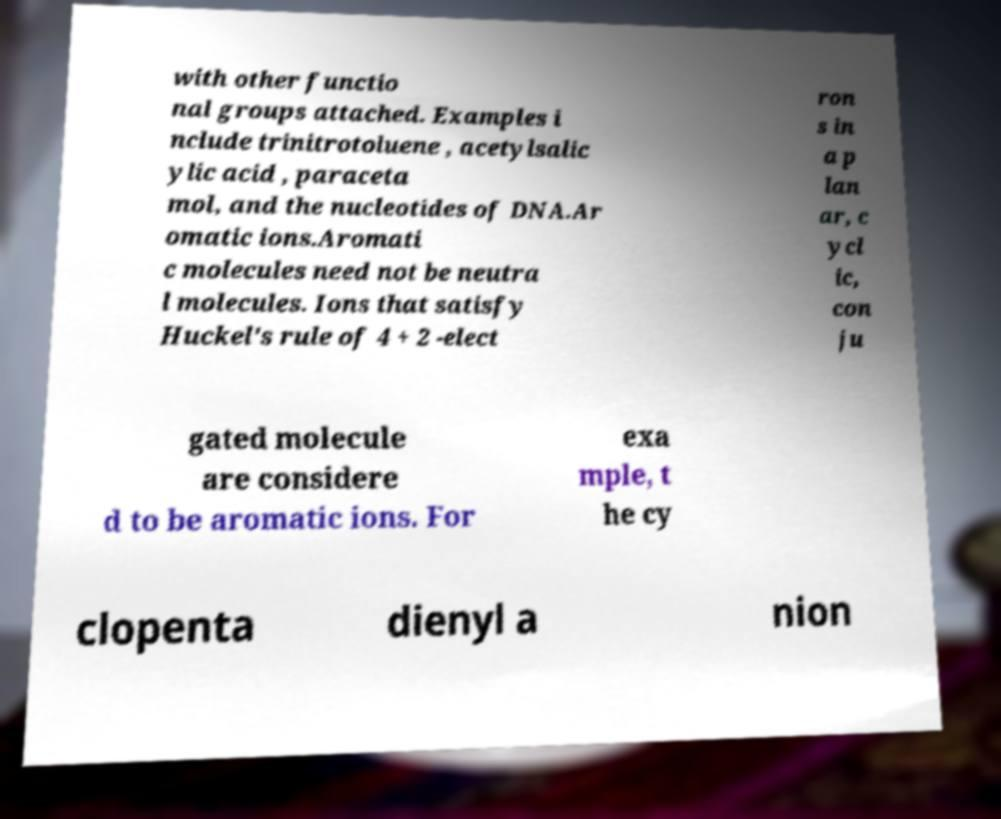Could you assist in decoding the text presented in this image and type it out clearly? with other functio nal groups attached. Examples i nclude trinitrotoluene , acetylsalic ylic acid , paraceta mol, and the nucleotides of DNA.Ar omatic ions.Aromati c molecules need not be neutra l molecules. Ions that satisfy Huckel's rule of 4 + 2 -elect ron s in a p lan ar, c ycl ic, con ju gated molecule are considere d to be aromatic ions. For exa mple, t he cy clopenta dienyl a nion 